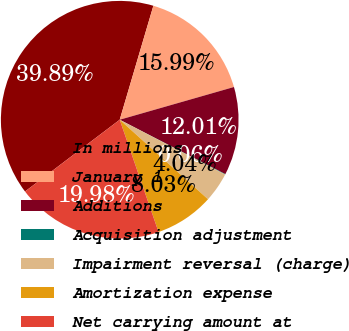Convert chart to OTSL. <chart><loc_0><loc_0><loc_500><loc_500><pie_chart><fcel>In millions<fcel>January 1<fcel>Additions<fcel>Acquisition adjustment<fcel>Impairment reversal (charge)<fcel>Amortization expense<fcel>Net carrying amount at<nl><fcel>39.89%<fcel>15.99%<fcel>12.01%<fcel>0.06%<fcel>4.04%<fcel>8.03%<fcel>19.98%<nl></chart> 